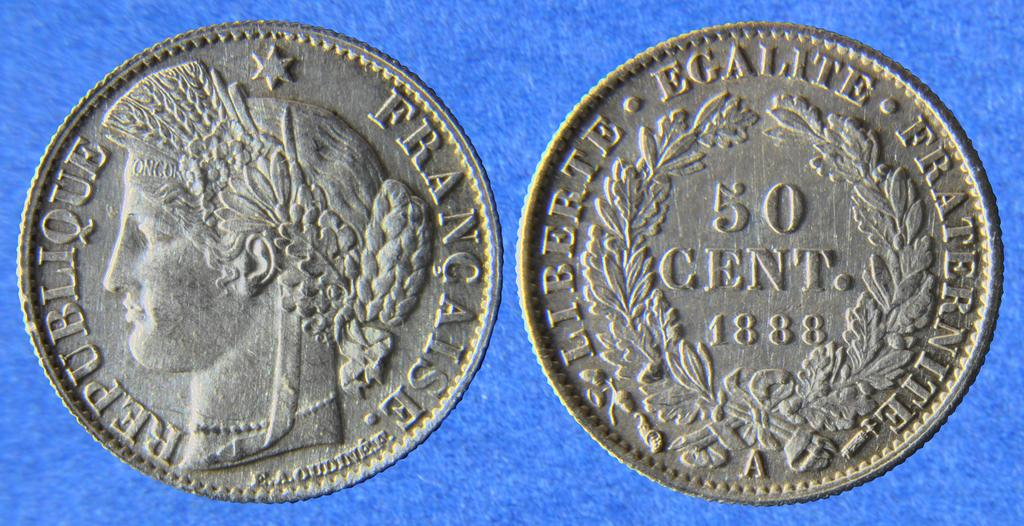Provide a one-sentence caption for the provided image. The front and back of a Republique of France 50 cent coint from 1888 is displayed. 